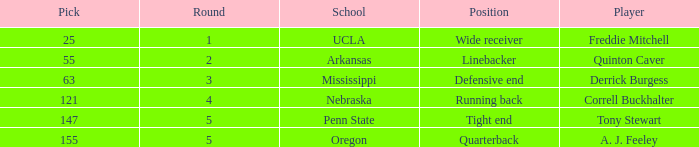Who was the player who was pick number 147? Tony Stewart. 